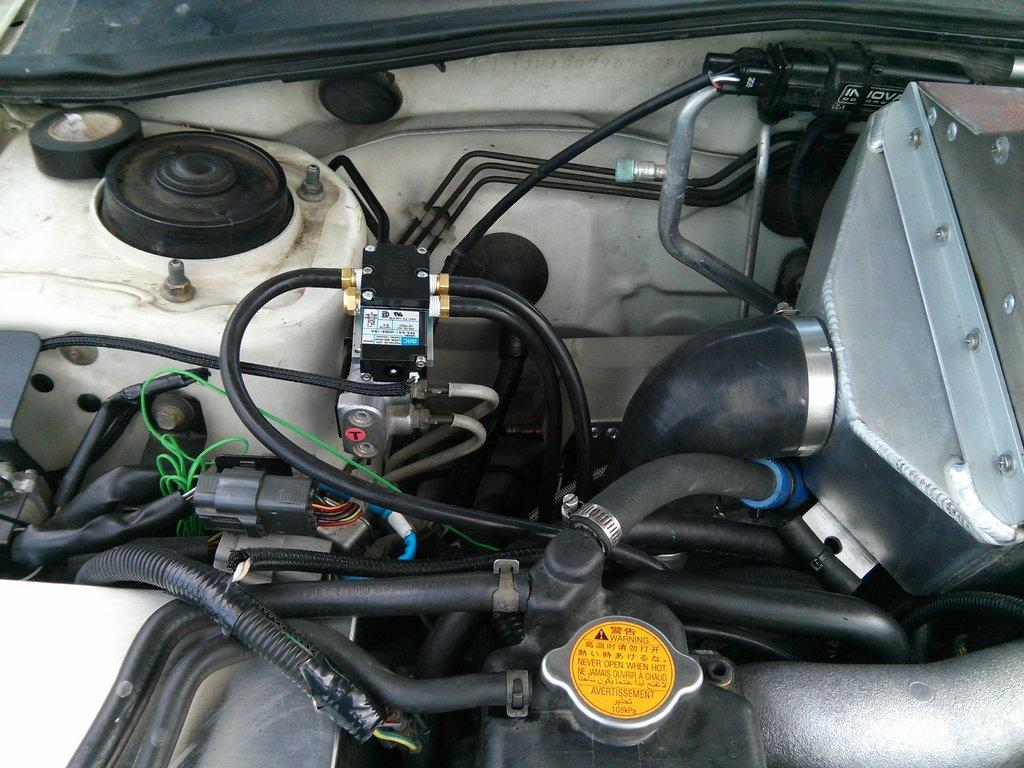What is the main object in the image? There is an engine in the image. What are some other objects visible in the image? There are pipes, rods, cables, and other objects in the image. Can you describe the location of the tape in the image? The tape is on the left side top of the image. How many legs does the ghost have in the image? There is no ghost present in the image, so it is not possible to determine the number of legs it might have. 